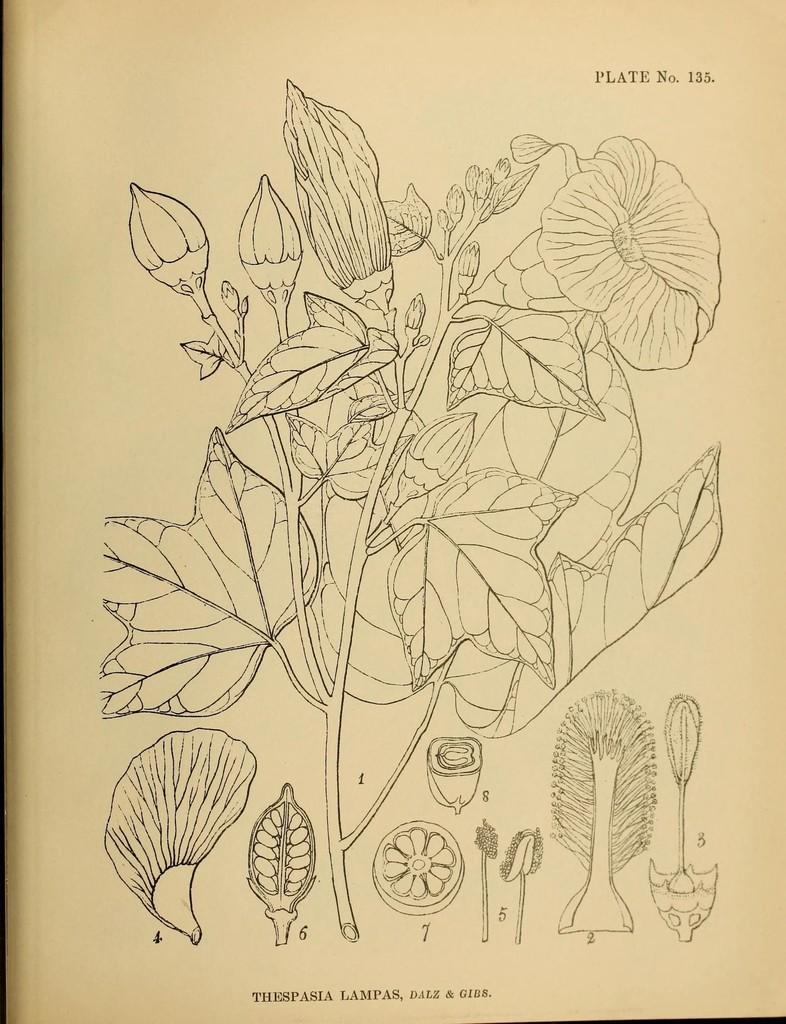In one or two sentences, can you explain what this image depicts? In this image I can see the diagram of the plant and I can also see few flowers and the background is in cream color. 